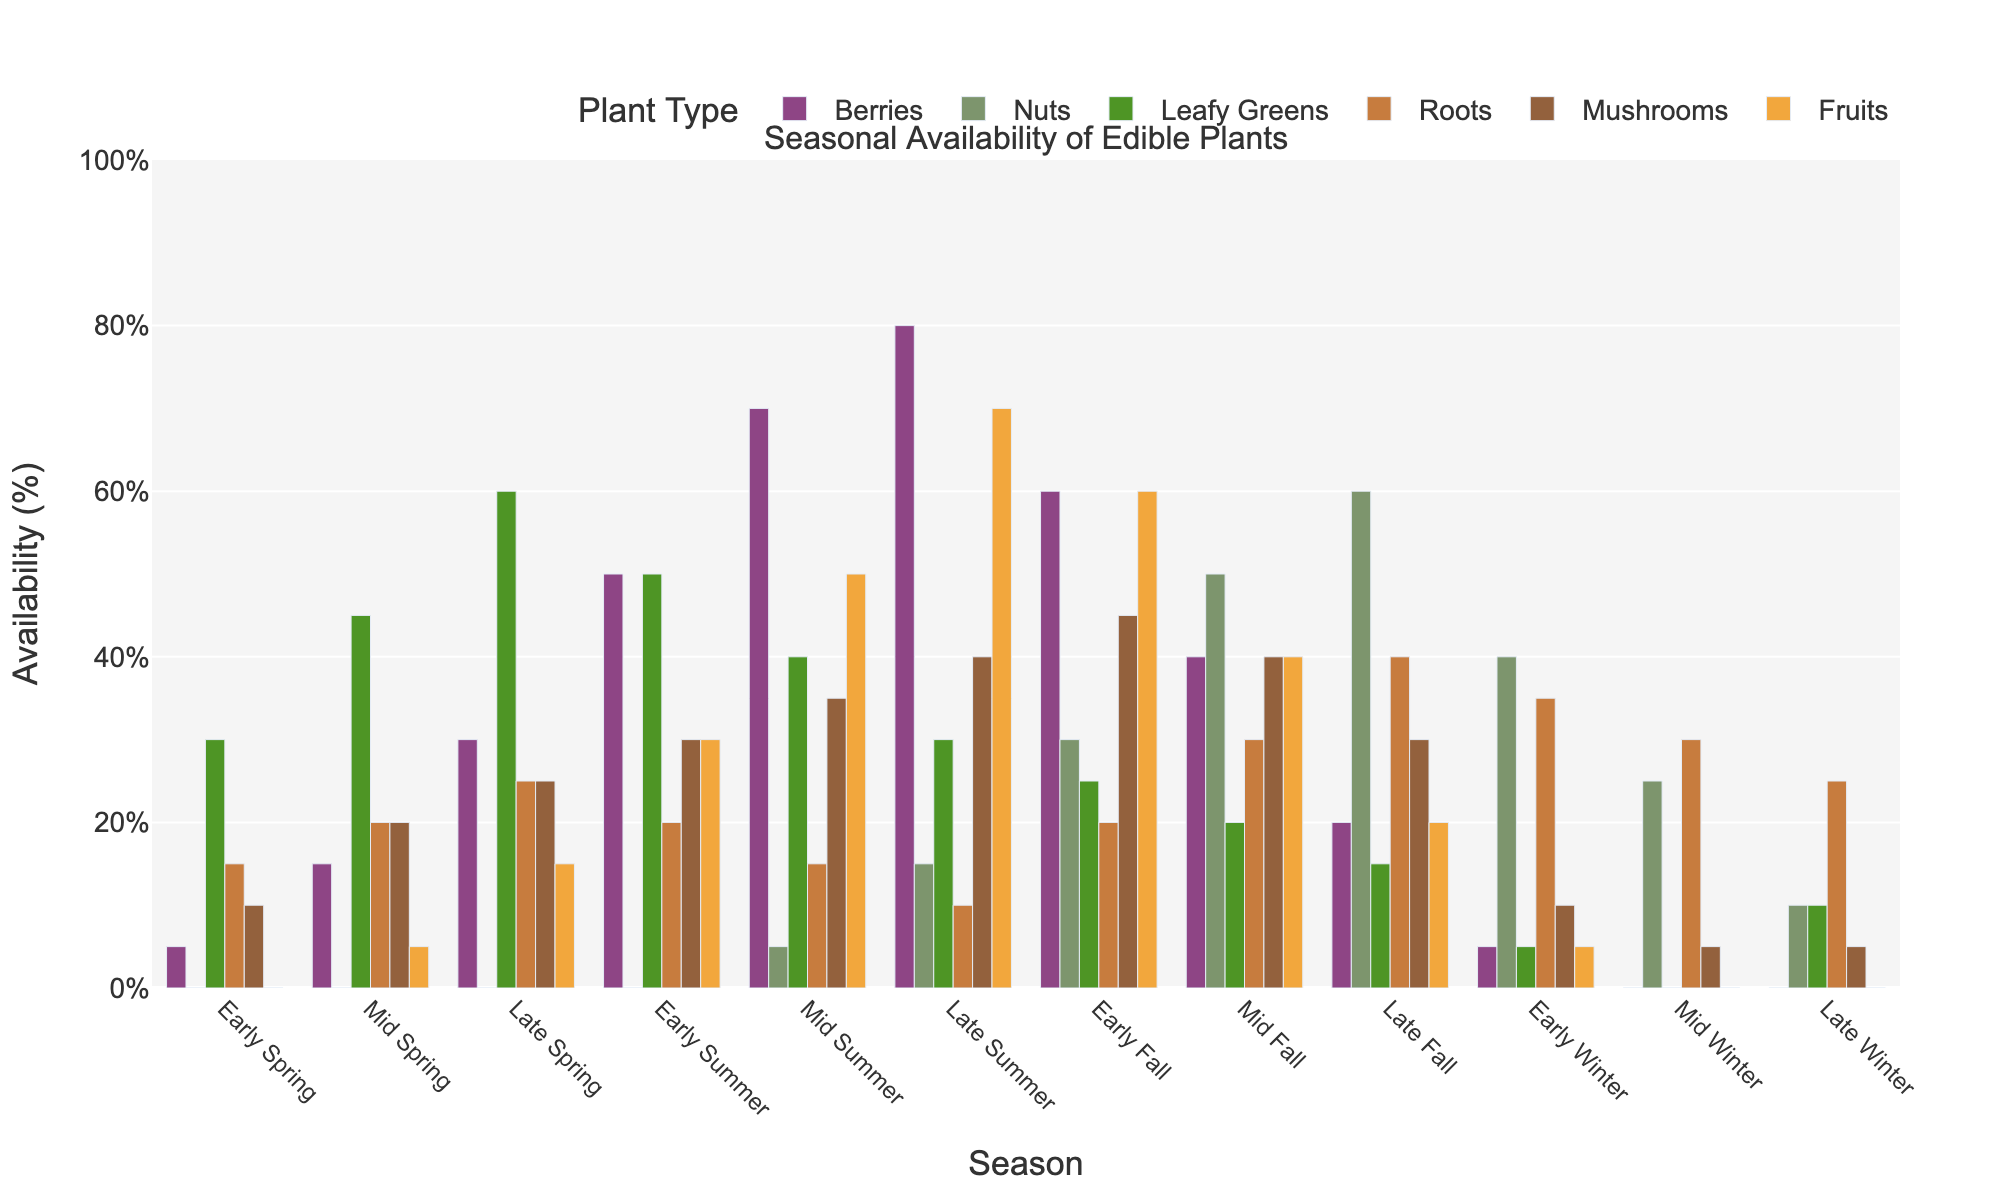What season has the highest availability of mushrooms? Look at the bar heights for mushrooms across all seasons and find the tallest bar. The highest is in Early Fall.
Answer: Early Fall Which type of plant is least available in Mid Winter? Check the bar heights for each plant type in the Mid Winter season and find the smallest bar. It's Leafy Greens with 0%.
Answer: Leafy Greens In which season are berries more available than leafy greens? Compare the bar heights for berries and leafy greens across all seasons and identify the seasons where the bar for berries is taller than for leafy greens. It's in Early Summer, Mid Summer, Late Summer, Early Fall, and Mid Fall.
Answer: Early Summer, Mid Summer, Late Summer, Early Fall, Mid Fall What’s the total availability of fruits in the summer seasons? Sum the fruits percentages across Early Summer, Mid Summer, and Late Summer. (30% + 50% + 70% = 150%)
Answer: 150% Which season has the most diverse availability of all plant types (greatest range of values)? Calculate the range of values (max value - min value) for each season and find the season with the greatest range. Mid Fall has the greatest range (50% - 20% = 30%).
Answer: Mid Fall In how many seasons is the availability of nuts greater than 10%? Check each season where the availability of nuts is greater than 10%. This occurs in Late Summer, Early Fall, Mid Fall, Late Fall, and Early Winter. There are 5 such seasons.
Answer: 5 Which plant type has the most stable availability throughout the year? Look at the fluctuation (range) in the bar heights for each plant type across all seasons. Nuts stay within a smaller range (0% - 60%) compared to the other plant types.
Answer: Nuts What is the average availability of leafy greens in Spring? Add the percentages of leafy greens for Early Spring, Mid Spring, and Late Spring, then divide by 3. (30 + 45 + 60) / 3 = 45
Answer: 45 How does the availability of roots in Early Fall compare to Late Winter? Look at the bar heights for roots in Early Fall and Late Winter. Early Fall has 20%, while Late Winter has 25%. So, it's 5% less in Early Fall compared to Late Winter.
Answer: 5% less Which three plant types peak in availability during Late Summer? Identify the highest bars in Late Summer and the corresponding plant types. Berries, Mushrooms, and Fruits peak in Late Summer at 80%, 40%, and 70%, respectively.
Answer: Berries, Mushrooms, Fruits 